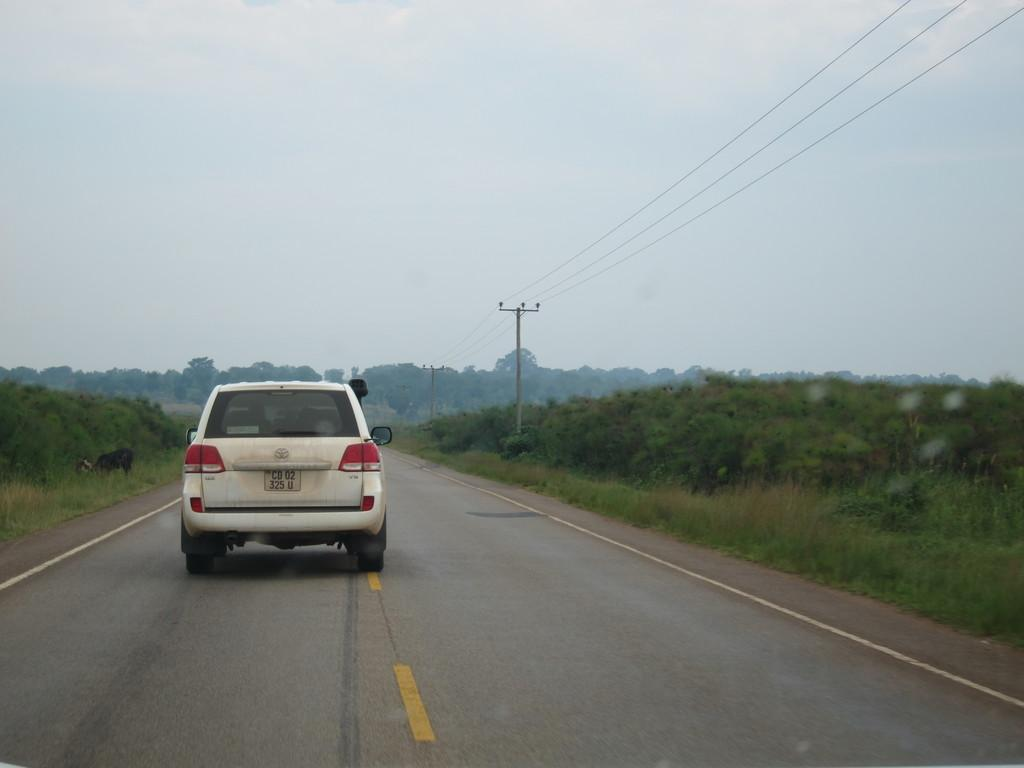What type of vehicle is in the image? There is a white car in the image. Where is the car located? The car is on the road. What can be seen at the bottom of the image? There is a road visible at the bottom of the image. What type of vegetation is present on the sides of the image? There are plants on the left and right sides of the image. What is visible in the sky at the top of the image? There are clouds in the sky at the top of the image. How long does it take for the soap to dissolve in the image? There is no soap present in the image, so it is not possible to determine how long it would take to dissolve. 